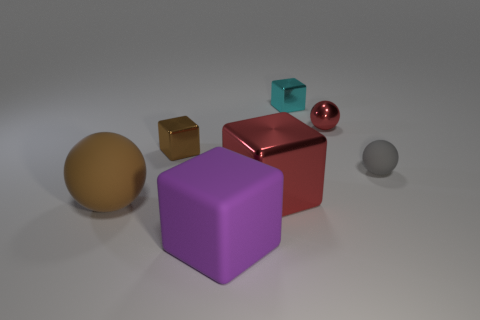Add 3 big metallic objects. How many objects exist? 10 Subtract all balls. How many objects are left? 4 Add 2 big red things. How many big red things are left? 3 Add 3 cyan cubes. How many cyan cubes exist? 4 Subtract 1 brown blocks. How many objects are left? 6 Subtract all cyan objects. Subtract all small cyan metal things. How many objects are left? 5 